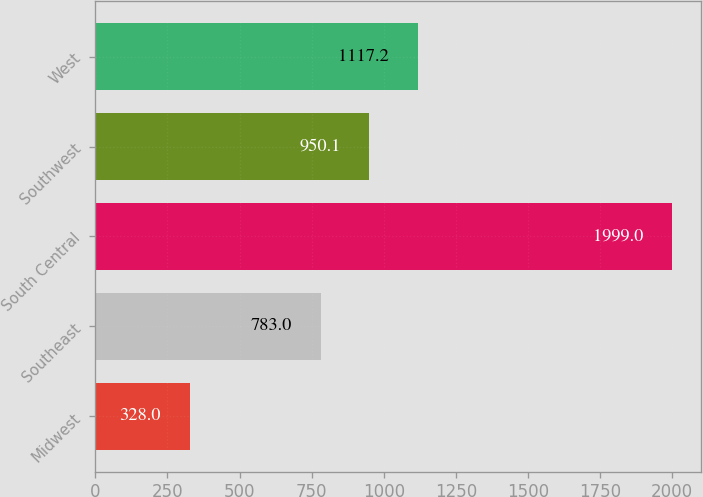Convert chart to OTSL. <chart><loc_0><loc_0><loc_500><loc_500><bar_chart><fcel>Midwest<fcel>Southeast<fcel>South Central<fcel>Southwest<fcel>West<nl><fcel>328<fcel>783<fcel>1999<fcel>950.1<fcel>1117.2<nl></chart> 